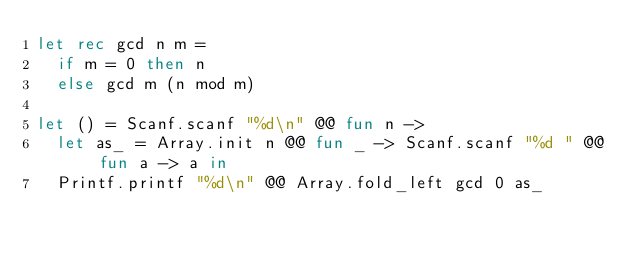<code> <loc_0><loc_0><loc_500><loc_500><_OCaml_>let rec gcd n m =
  if m = 0 then n
  else gcd m (n mod m)

let () = Scanf.scanf "%d\n" @@ fun n ->
  let as_ = Array.init n @@ fun _ -> Scanf.scanf "%d " @@ fun a -> a in
  Printf.printf "%d\n" @@ Array.fold_left gcd 0 as_
</code> 